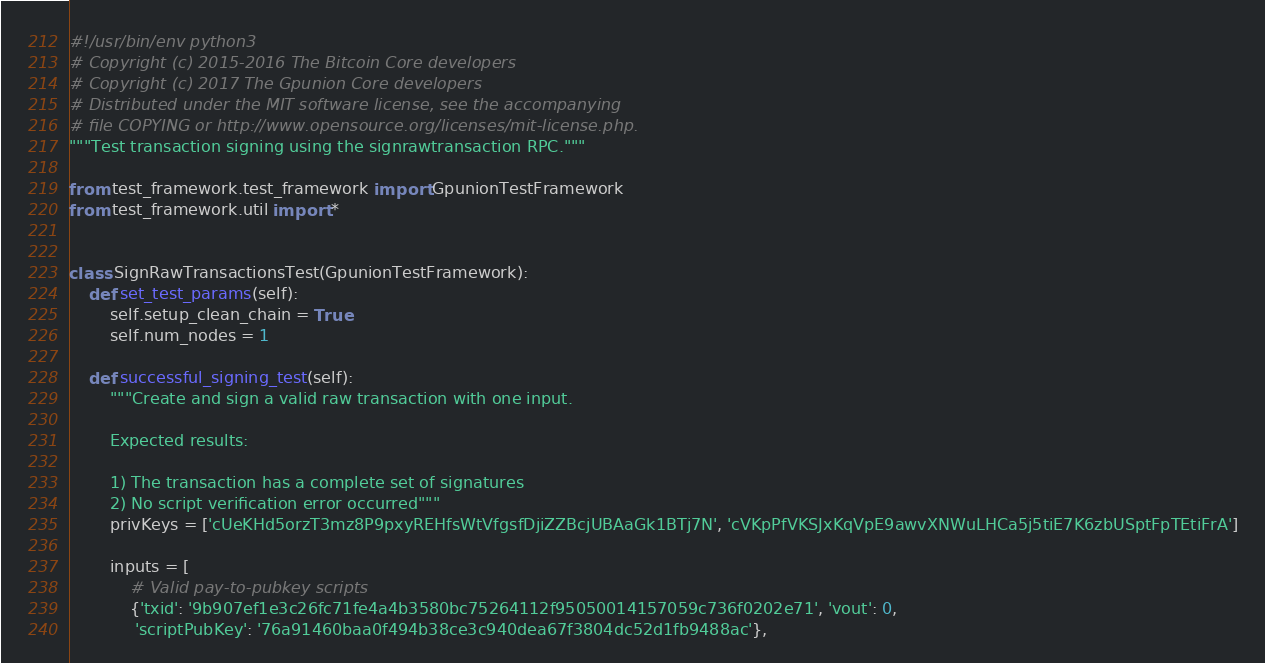Convert code to text. <code><loc_0><loc_0><loc_500><loc_500><_Python_>#!/usr/bin/env python3
# Copyright (c) 2015-2016 The Bitcoin Core developers
# Copyright (c) 2017 The Gpunion Core developers
# Distributed under the MIT software license, see the accompanying
# file COPYING or http://www.opensource.org/licenses/mit-license.php.
"""Test transaction signing using the signrawtransaction RPC."""

from test_framework.test_framework import GpunionTestFramework
from test_framework.util import *


class SignRawTransactionsTest(GpunionTestFramework):
    def set_test_params(self):
        self.setup_clean_chain = True
        self.num_nodes = 1

    def successful_signing_test(self):
        """Create and sign a valid raw transaction with one input.

        Expected results:

        1) The transaction has a complete set of signatures
        2) No script verification error occurred"""
        privKeys = ['cUeKHd5orzT3mz8P9pxyREHfsWtVfgsfDjiZZBcjUBAaGk1BTj7N', 'cVKpPfVKSJxKqVpE9awvXNWuLHCa5j5tiE7K6zbUSptFpTEtiFrA']

        inputs = [
            # Valid pay-to-pubkey scripts
            {'txid': '9b907ef1e3c26fc71fe4a4b3580bc75264112f95050014157059c736f0202e71', 'vout': 0,
             'scriptPubKey': '76a91460baa0f494b38ce3c940dea67f3804dc52d1fb9488ac'},</code> 